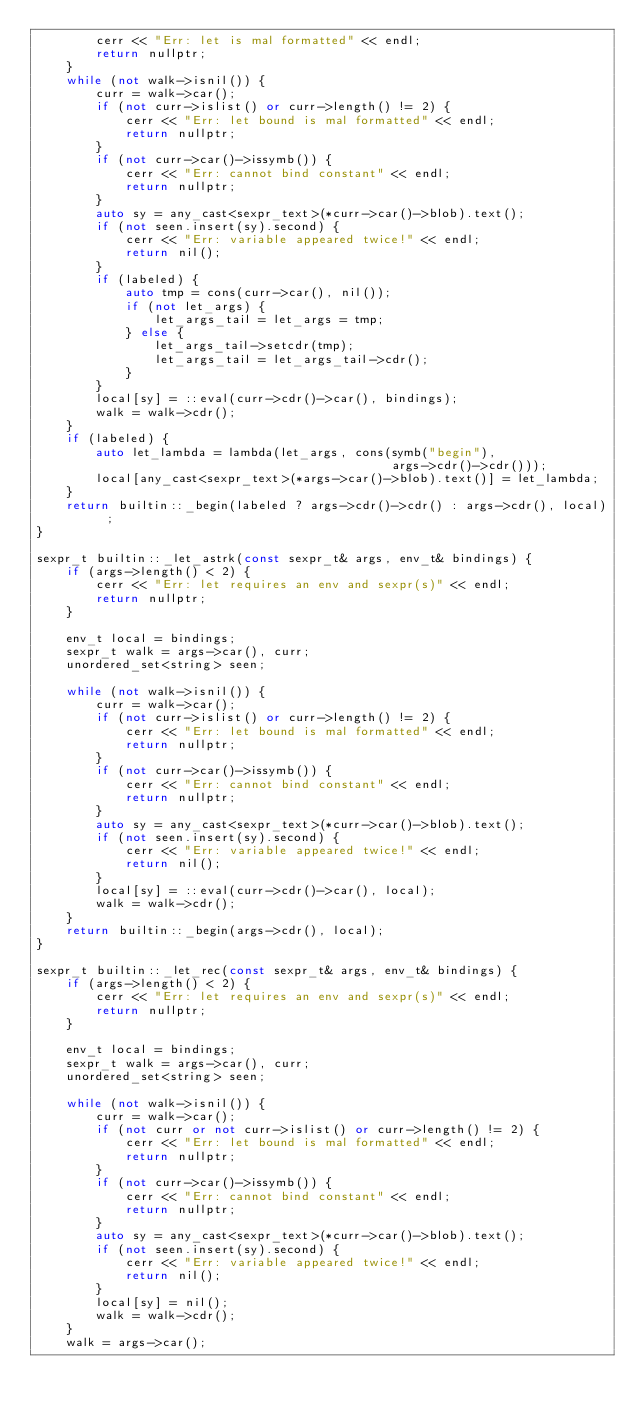<code> <loc_0><loc_0><loc_500><loc_500><_C++_>        cerr << "Err: let is mal formatted" << endl;
        return nullptr;
    }
    while (not walk->isnil()) {
        curr = walk->car();
        if (not curr->islist() or curr->length() != 2) {
            cerr << "Err: let bound is mal formatted" << endl;
            return nullptr;
        }
        if (not curr->car()->issymb()) {
            cerr << "Err: cannot bind constant" << endl;
            return nullptr;
        }
        auto sy = any_cast<sexpr_text>(*curr->car()->blob).text();
        if (not seen.insert(sy).second) {
            cerr << "Err: variable appeared twice!" << endl;
            return nil();
        }
        if (labeled) {
            auto tmp = cons(curr->car(), nil());
            if (not let_args) {
                let_args_tail = let_args = tmp;
            } else {
                let_args_tail->setcdr(tmp);
                let_args_tail = let_args_tail->cdr();
            }
        }
        local[sy] = ::eval(curr->cdr()->car(), bindings);
        walk = walk->cdr();
    }
    if (labeled) {
        auto let_lambda = lambda(let_args, cons(symb("begin"),
                                                args->cdr()->cdr()));
        local[any_cast<sexpr_text>(*args->car()->blob).text()] = let_lambda;
    }
    return builtin::_begin(labeled ? args->cdr()->cdr() : args->cdr(), local) ;
}

sexpr_t builtin::_let_astrk(const sexpr_t& args, env_t& bindings) {
    if (args->length() < 2) {
        cerr << "Err: let requires an env and sexpr(s)" << endl;
        return nullptr;
    }

    env_t local = bindings;
    sexpr_t walk = args->car(), curr;
    unordered_set<string> seen;

    while (not walk->isnil()) {
        curr = walk->car();
        if (not curr->islist() or curr->length() != 2) {
            cerr << "Err: let bound is mal formatted" << endl;
            return nullptr;
        }
        if (not curr->car()->issymb()) {
            cerr << "Err: cannot bind constant" << endl;
            return nullptr;
        }
        auto sy = any_cast<sexpr_text>(*curr->car()->blob).text();
        if (not seen.insert(sy).second) {
            cerr << "Err: variable appeared twice!" << endl;
            return nil();
        }
        local[sy] = ::eval(curr->cdr()->car(), local);
        walk = walk->cdr();
    }
    return builtin::_begin(args->cdr(), local);
}

sexpr_t builtin::_let_rec(const sexpr_t& args, env_t& bindings) {
    if (args->length() < 2) {
        cerr << "Err: let requires an env and sexpr(s)" << endl;
        return nullptr;
    }

    env_t local = bindings;
    sexpr_t walk = args->car(), curr;
    unordered_set<string> seen;

    while (not walk->isnil()) {
        curr = walk->car();
        if (not curr or not curr->islist() or curr->length() != 2) {
            cerr << "Err: let bound is mal formatted" << endl;
            return nullptr;
        }
        if (not curr->car()->issymb()) {
            cerr << "Err: cannot bind constant" << endl;
            return nullptr;
        }
        auto sy = any_cast<sexpr_text>(*curr->car()->blob).text();
        if (not seen.insert(sy).second) {
            cerr << "Err: variable appeared twice!" << endl;
            return nil();
        }
        local[sy] = nil();
        walk = walk->cdr();
    }
    walk = args->car();</code> 